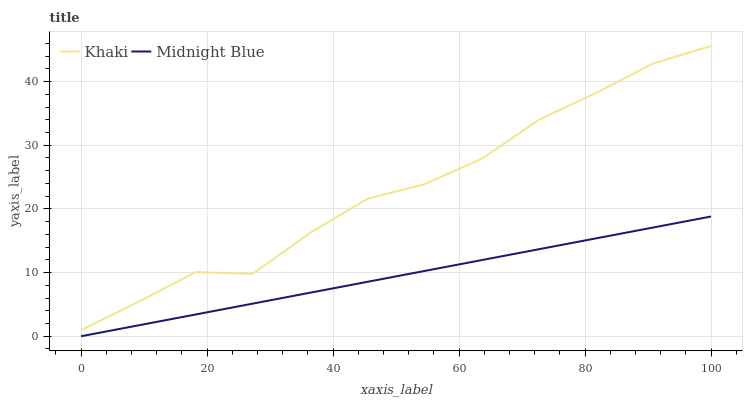Does Midnight Blue have the minimum area under the curve?
Answer yes or no. Yes. Does Khaki have the maximum area under the curve?
Answer yes or no. Yes. Does Midnight Blue have the maximum area under the curve?
Answer yes or no. No. Is Midnight Blue the smoothest?
Answer yes or no. Yes. Is Khaki the roughest?
Answer yes or no. Yes. Is Midnight Blue the roughest?
Answer yes or no. No. Does Midnight Blue have the lowest value?
Answer yes or no. Yes. Does Khaki have the highest value?
Answer yes or no. Yes. Does Midnight Blue have the highest value?
Answer yes or no. No. Is Midnight Blue less than Khaki?
Answer yes or no. Yes. Is Khaki greater than Midnight Blue?
Answer yes or no. Yes. Does Midnight Blue intersect Khaki?
Answer yes or no. No. 